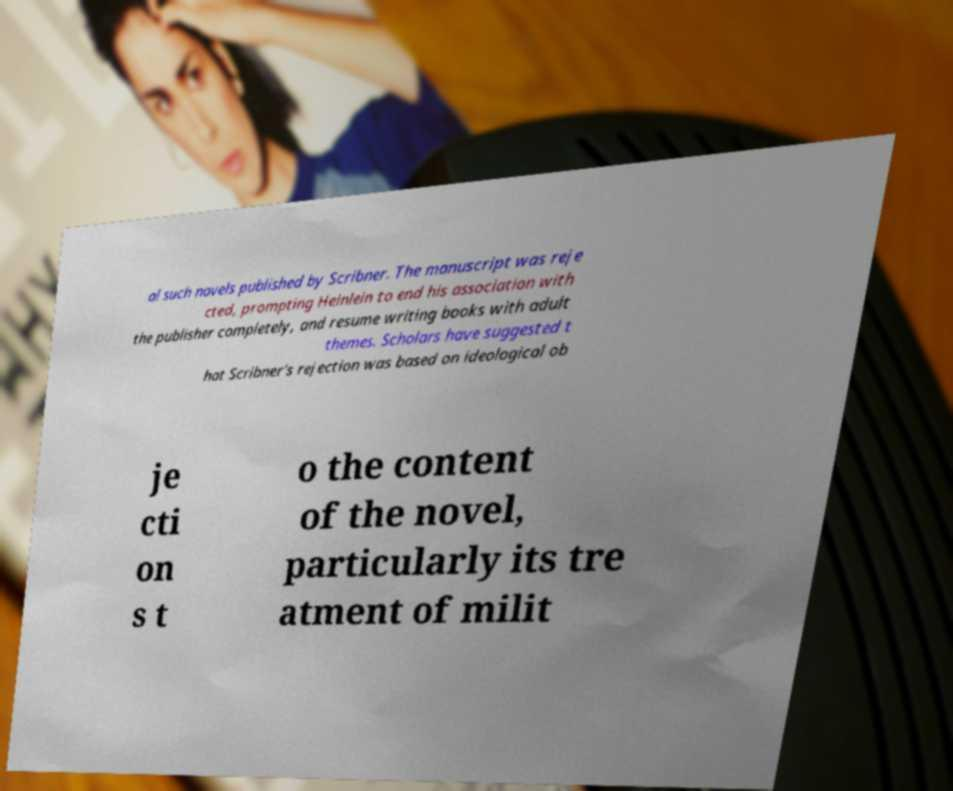Please identify and transcribe the text found in this image. al such novels published by Scribner. The manuscript was reje cted, prompting Heinlein to end his association with the publisher completely, and resume writing books with adult themes. Scholars have suggested t hat Scribner's rejection was based on ideological ob je cti on s t o the content of the novel, particularly its tre atment of milit 